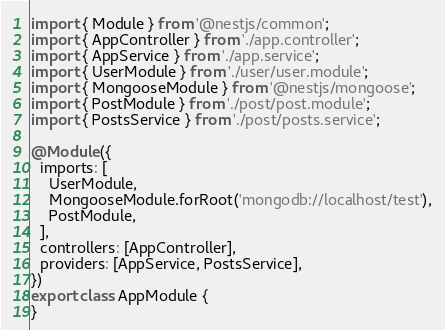Convert code to text. <code><loc_0><loc_0><loc_500><loc_500><_TypeScript_>import { Module } from '@nestjs/common';
import { AppController } from './app.controller';
import { AppService } from './app.service';
import { UserModule } from './user/user.module';
import { MongooseModule } from '@nestjs/mongoose';
import { PostModule } from './post/post.module';
import { PostsService } from './post/posts.service';

@Module({
  imports: [
    UserModule,
    MongooseModule.forRoot('mongodb://localhost/test'),
    PostModule,
  ],
  controllers: [AppController],
  providers: [AppService, PostsService],
})
export class AppModule {
}
</code> 